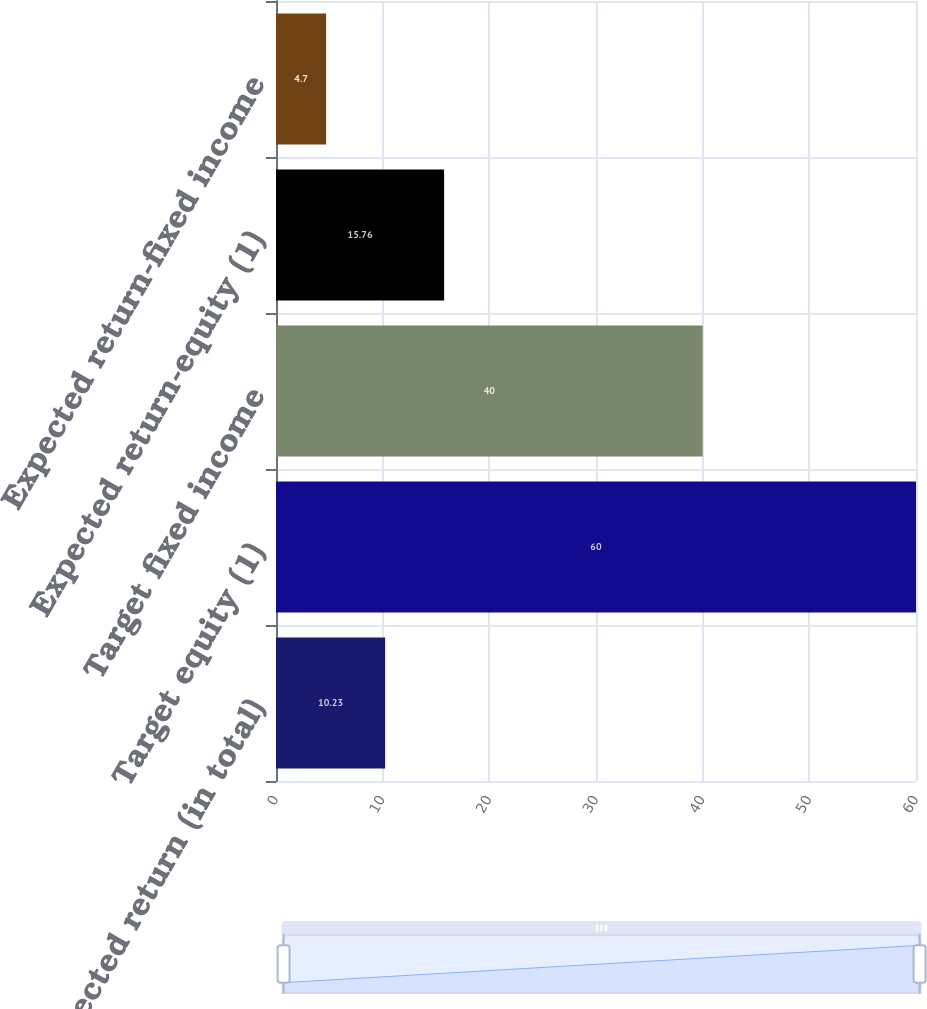<chart> <loc_0><loc_0><loc_500><loc_500><bar_chart><fcel>Expected return (in total)<fcel>Target equity (1)<fcel>Target fixed income<fcel>Expected return-equity (1)<fcel>Expected return-fixed income<nl><fcel>10.23<fcel>60<fcel>40<fcel>15.76<fcel>4.7<nl></chart> 